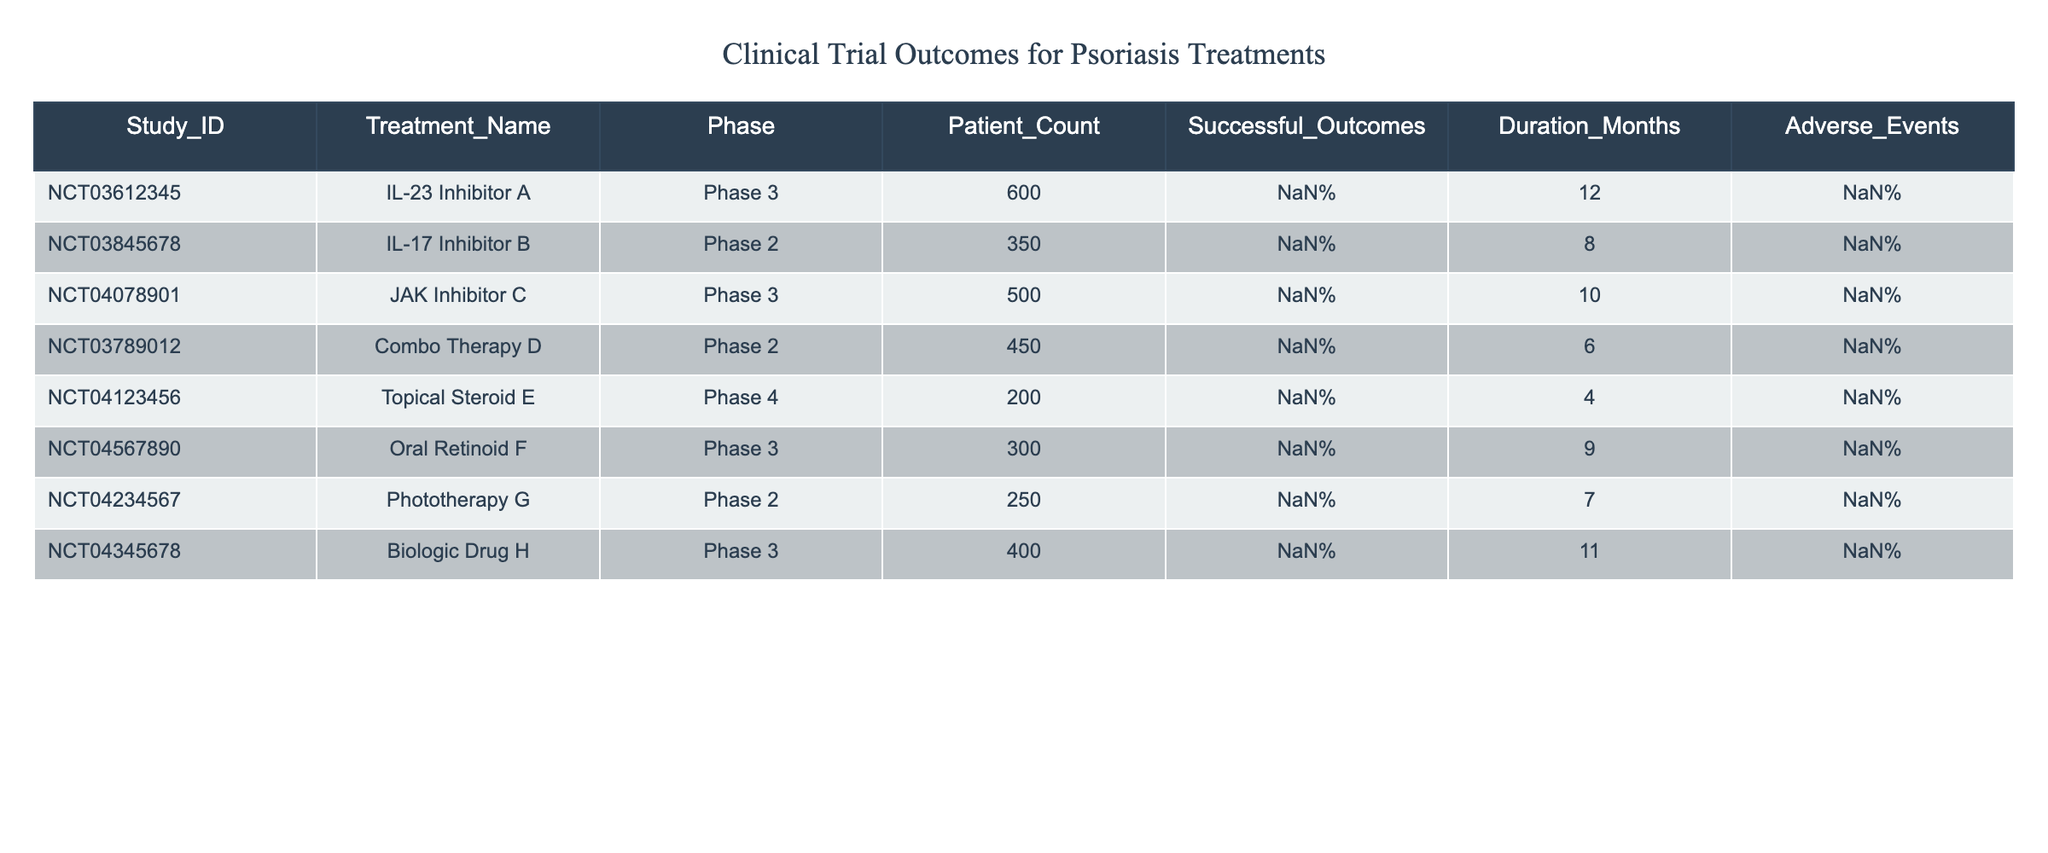What percentage of patients had successful outcomes with the JAK Inhibitor C treatment? The table shows that the JAK Inhibitor C treatment had a successful outcome percentage of 78%.
Answer: 78% Which treatment had the highest percentage of successful outcomes? By comparing the successful outcome percentages, Combo Therapy D is noted at 82%, which is the highest among all treatments listed.
Answer: Combo Therapy D Is the patient count for the Topical Steroid E above or below 300? The Topical Steroid E has a patient count of 200, which is below 300.
Answer: Below What is the average percentage of successful outcomes across all treatments listed? Adding the successful outcome percentages: 75 + 70 + 78 + 82 + 65 + 67 + 74 + 80, which totals 576. Dividing by the number of treatments (8), the average is 72%.
Answer: 72% Did any treatment in Phase 2 have a patient count greater than 400? A check of the treatment data shows that the Combo Therapy D with 450 patients is in Phase 2; therefore, there are treatments in Phase 2 with a count greater than 400.
Answer: Yes What is the range of the duration in months for all treatments? The duration varies from a minimum of 4 months (Topical Steroid E) to a maximum of 12 months (IL-23 Inhibitor A). Thus, the range is 12 - 4 = 8 months.
Answer: 8 months Are there any treatments with adverse events over 5%? The table lists Combo Therapy D with 10% and IL-17 Inhibitor B with 8%, both indicating that there are treatments with adverse events over 5%.
Answer: Yes How many Phase 3 treatments had successful outcomes of 80% or higher? The treatments under Phase 3 with successful outcomes of 80% or higher are JAK Inhibitor C (78%) and Biologic Drug H (80%). Thus, there are two such treatments.
Answer: 2 